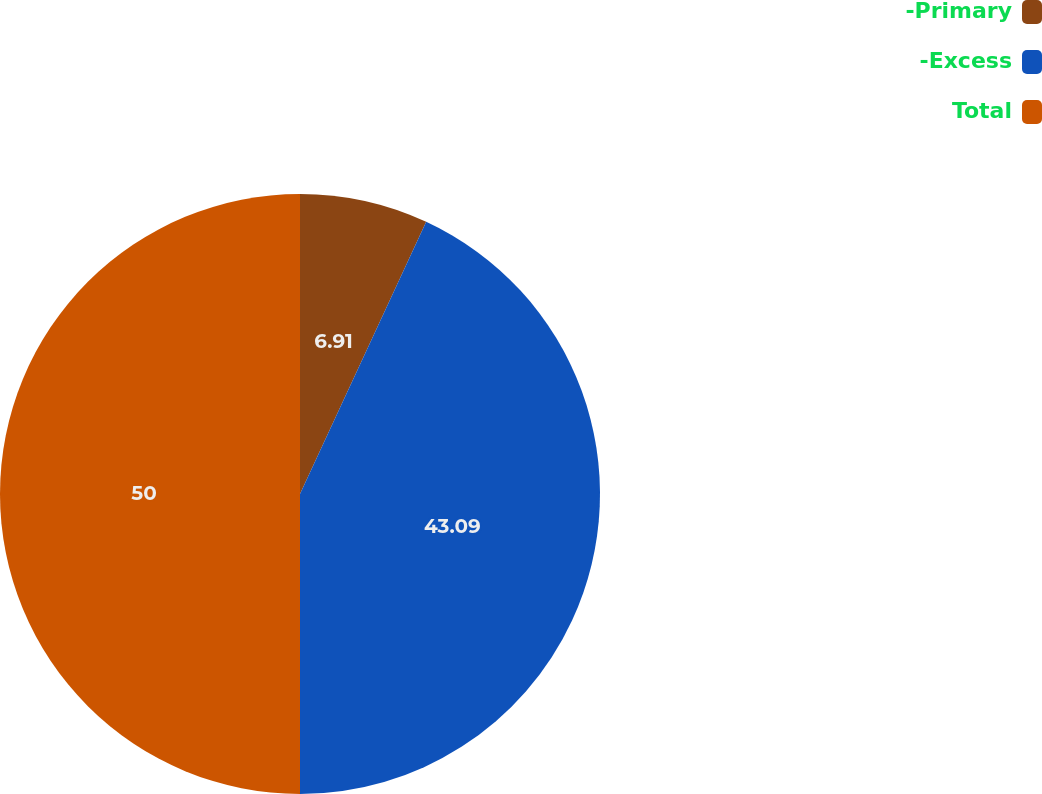<chart> <loc_0><loc_0><loc_500><loc_500><pie_chart><fcel>-Primary<fcel>-Excess<fcel>Total<nl><fcel>6.91%<fcel>43.09%<fcel>50.0%<nl></chart> 